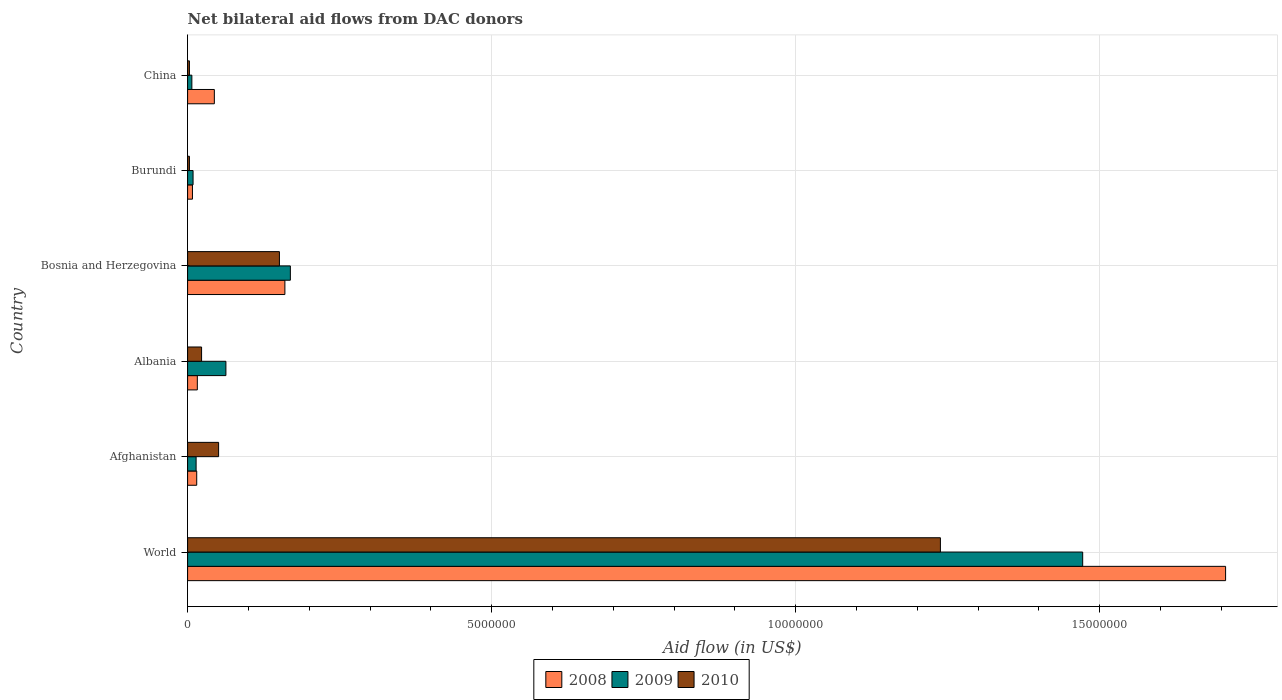How many groups of bars are there?
Ensure brevity in your answer.  6. Are the number of bars on each tick of the Y-axis equal?
Your answer should be compact. Yes. How many bars are there on the 4th tick from the top?
Provide a short and direct response. 3. How many bars are there on the 2nd tick from the bottom?
Provide a short and direct response. 3. What is the label of the 4th group of bars from the top?
Ensure brevity in your answer.  Albania. In how many cases, is the number of bars for a given country not equal to the number of legend labels?
Provide a succinct answer. 0. What is the net bilateral aid flow in 2010 in Albania?
Give a very brief answer. 2.30e+05. Across all countries, what is the maximum net bilateral aid flow in 2010?
Offer a very short reply. 1.24e+07. In which country was the net bilateral aid flow in 2008 minimum?
Provide a succinct answer. Burundi. What is the total net bilateral aid flow in 2010 in the graph?
Your response must be concise. 1.47e+07. What is the difference between the net bilateral aid flow in 2009 in Bosnia and Herzegovina and that in Burundi?
Provide a succinct answer. 1.60e+06. What is the difference between the net bilateral aid flow in 2009 in China and the net bilateral aid flow in 2010 in Afghanistan?
Your answer should be compact. -4.40e+05. What is the average net bilateral aid flow in 2008 per country?
Give a very brief answer. 3.25e+06. What is the difference between the net bilateral aid flow in 2010 and net bilateral aid flow in 2009 in World?
Your answer should be very brief. -2.34e+06. What is the ratio of the net bilateral aid flow in 2010 in Bosnia and Herzegovina to that in Burundi?
Provide a succinct answer. 50.33. Is the net bilateral aid flow in 2008 in Burundi less than that in World?
Make the answer very short. Yes. What is the difference between the highest and the second highest net bilateral aid flow in 2009?
Keep it short and to the point. 1.30e+07. What is the difference between the highest and the lowest net bilateral aid flow in 2009?
Your answer should be very brief. 1.46e+07. What does the 2nd bar from the bottom in Afghanistan represents?
Your answer should be very brief. 2009. Is it the case that in every country, the sum of the net bilateral aid flow in 2009 and net bilateral aid flow in 2008 is greater than the net bilateral aid flow in 2010?
Keep it short and to the point. No. Are all the bars in the graph horizontal?
Provide a succinct answer. Yes. How many countries are there in the graph?
Make the answer very short. 6. Are the values on the major ticks of X-axis written in scientific E-notation?
Keep it short and to the point. No. Does the graph contain grids?
Give a very brief answer. Yes. How many legend labels are there?
Make the answer very short. 3. How are the legend labels stacked?
Your answer should be compact. Horizontal. What is the title of the graph?
Offer a very short reply. Net bilateral aid flows from DAC donors. Does "1962" appear as one of the legend labels in the graph?
Ensure brevity in your answer.  No. What is the label or title of the X-axis?
Provide a short and direct response. Aid flow (in US$). What is the label or title of the Y-axis?
Ensure brevity in your answer.  Country. What is the Aid flow (in US$) of 2008 in World?
Ensure brevity in your answer.  1.71e+07. What is the Aid flow (in US$) in 2009 in World?
Make the answer very short. 1.47e+07. What is the Aid flow (in US$) in 2010 in World?
Your answer should be compact. 1.24e+07. What is the Aid flow (in US$) of 2009 in Afghanistan?
Ensure brevity in your answer.  1.40e+05. What is the Aid flow (in US$) in 2010 in Afghanistan?
Your answer should be very brief. 5.10e+05. What is the Aid flow (in US$) in 2008 in Albania?
Your answer should be compact. 1.60e+05. What is the Aid flow (in US$) in 2009 in Albania?
Give a very brief answer. 6.30e+05. What is the Aid flow (in US$) of 2010 in Albania?
Offer a very short reply. 2.30e+05. What is the Aid flow (in US$) of 2008 in Bosnia and Herzegovina?
Your response must be concise. 1.60e+06. What is the Aid flow (in US$) in 2009 in Bosnia and Herzegovina?
Provide a succinct answer. 1.69e+06. What is the Aid flow (in US$) of 2010 in Bosnia and Herzegovina?
Provide a succinct answer. 1.51e+06. What is the Aid flow (in US$) in 2008 in China?
Keep it short and to the point. 4.40e+05. What is the Aid flow (in US$) of 2009 in China?
Provide a succinct answer. 7.00e+04. What is the Aid flow (in US$) in 2010 in China?
Your response must be concise. 3.00e+04. Across all countries, what is the maximum Aid flow (in US$) of 2008?
Give a very brief answer. 1.71e+07. Across all countries, what is the maximum Aid flow (in US$) of 2009?
Offer a terse response. 1.47e+07. Across all countries, what is the maximum Aid flow (in US$) of 2010?
Your answer should be compact. 1.24e+07. Across all countries, what is the minimum Aid flow (in US$) of 2008?
Ensure brevity in your answer.  8.00e+04. Across all countries, what is the minimum Aid flow (in US$) in 2009?
Ensure brevity in your answer.  7.00e+04. What is the total Aid flow (in US$) in 2008 in the graph?
Ensure brevity in your answer.  1.95e+07. What is the total Aid flow (in US$) of 2009 in the graph?
Offer a very short reply. 1.73e+07. What is the total Aid flow (in US$) in 2010 in the graph?
Offer a terse response. 1.47e+07. What is the difference between the Aid flow (in US$) of 2008 in World and that in Afghanistan?
Provide a succinct answer. 1.69e+07. What is the difference between the Aid flow (in US$) of 2009 in World and that in Afghanistan?
Offer a terse response. 1.46e+07. What is the difference between the Aid flow (in US$) of 2010 in World and that in Afghanistan?
Offer a terse response. 1.19e+07. What is the difference between the Aid flow (in US$) of 2008 in World and that in Albania?
Your answer should be very brief. 1.69e+07. What is the difference between the Aid flow (in US$) in 2009 in World and that in Albania?
Offer a terse response. 1.41e+07. What is the difference between the Aid flow (in US$) of 2010 in World and that in Albania?
Offer a terse response. 1.22e+07. What is the difference between the Aid flow (in US$) in 2008 in World and that in Bosnia and Herzegovina?
Make the answer very short. 1.55e+07. What is the difference between the Aid flow (in US$) of 2009 in World and that in Bosnia and Herzegovina?
Make the answer very short. 1.30e+07. What is the difference between the Aid flow (in US$) in 2010 in World and that in Bosnia and Herzegovina?
Make the answer very short. 1.09e+07. What is the difference between the Aid flow (in US$) of 2008 in World and that in Burundi?
Make the answer very short. 1.70e+07. What is the difference between the Aid flow (in US$) of 2009 in World and that in Burundi?
Keep it short and to the point. 1.46e+07. What is the difference between the Aid flow (in US$) in 2010 in World and that in Burundi?
Provide a succinct answer. 1.24e+07. What is the difference between the Aid flow (in US$) in 2008 in World and that in China?
Give a very brief answer. 1.66e+07. What is the difference between the Aid flow (in US$) of 2009 in World and that in China?
Offer a very short reply. 1.46e+07. What is the difference between the Aid flow (in US$) in 2010 in World and that in China?
Your response must be concise. 1.24e+07. What is the difference between the Aid flow (in US$) of 2008 in Afghanistan and that in Albania?
Offer a very short reply. -10000. What is the difference between the Aid flow (in US$) in 2009 in Afghanistan and that in Albania?
Your response must be concise. -4.90e+05. What is the difference between the Aid flow (in US$) in 2008 in Afghanistan and that in Bosnia and Herzegovina?
Keep it short and to the point. -1.45e+06. What is the difference between the Aid flow (in US$) of 2009 in Afghanistan and that in Bosnia and Herzegovina?
Offer a very short reply. -1.55e+06. What is the difference between the Aid flow (in US$) in 2009 in Afghanistan and that in Burundi?
Your answer should be compact. 5.00e+04. What is the difference between the Aid flow (in US$) in 2010 in Afghanistan and that in China?
Your answer should be compact. 4.80e+05. What is the difference between the Aid flow (in US$) in 2008 in Albania and that in Bosnia and Herzegovina?
Offer a very short reply. -1.44e+06. What is the difference between the Aid flow (in US$) of 2009 in Albania and that in Bosnia and Herzegovina?
Offer a very short reply. -1.06e+06. What is the difference between the Aid flow (in US$) of 2010 in Albania and that in Bosnia and Herzegovina?
Provide a short and direct response. -1.28e+06. What is the difference between the Aid flow (in US$) of 2009 in Albania and that in Burundi?
Offer a very short reply. 5.40e+05. What is the difference between the Aid flow (in US$) of 2008 in Albania and that in China?
Offer a terse response. -2.80e+05. What is the difference between the Aid flow (in US$) of 2009 in Albania and that in China?
Your answer should be compact. 5.60e+05. What is the difference between the Aid flow (in US$) in 2008 in Bosnia and Herzegovina and that in Burundi?
Your answer should be compact. 1.52e+06. What is the difference between the Aid flow (in US$) of 2009 in Bosnia and Herzegovina and that in Burundi?
Ensure brevity in your answer.  1.60e+06. What is the difference between the Aid flow (in US$) in 2010 in Bosnia and Herzegovina and that in Burundi?
Your response must be concise. 1.48e+06. What is the difference between the Aid flow (in US$) of 2008 in Bosnia and Herzegovina and that in China?
Your answer should be very brief. 1.16e+06. What is the difference between the Aid flow (in US$) of 2009 in Bosnia and Herzegovina and that in China?
Make the answer very short. 1.62e+06. What is the difference between the Aid flow (in US$) of 2010 in Bosnia and Herzegovina and that in China?
Your answer should be very brief. 1.48e+06. What is the difference between the Aid flow (in US$) of 2008 in Burundi and that in China?
Your response must be concise. -3.60e+05. What is the difference between the Aid flow (in US$) of 2008 in World and the Aid flow (in US$) of 2009 in Afghanistan?
Offer a very short reply. 1.69e+07. What is the difference between the Aid flow (in US$) of 2008 in World and the Aid flow (in US$) of 2010 in Afghanistan?
Provide a short and direct response. 1.66e+07. What is the difference between the Aid flow (in US$) of 2009 in World and the Aid flow (in US$) of 2010 in Afghanistan?
Offer a very short reply. 1.42e+07. What is the difference between the Aid flow (in US$) of 2008 in World and the Aid flow (in US$) of 2009 in Albania?
Your answer should be compact. 1.64e+07. What is the difference between the Aid flow (in US$) in 2008 in World and the Aid flow (in US$) in 2010 in Albania?
Provide a short and direct response. 1.68e+07. What is the difference between the Aid flow (in US$) of 2009 in World and the Aid flow (in US$) of 2010 in Albania?
Your response must be concise. 1.45e+07. What is the difference between the Aid flow (in US$) in 2008 in World and the Aid flow (in US$) in 2009 in Bosnia and Herzegovina?
Your answer should be compact. 1.54e+07. What is the difference between the Aid flow (in US$) in 2008 in World and the Aid flow (in US$) in 2010 in Bosnia and Herzegovina?
Your answer should be very brief. 1.56e+07. What is the difference between the Aid flow (in US$) of 2009 in World and the Aid flow (in US$) of 2010 in Bosnia and Herzegovina?
Ensure brevity in your answer.  1.32e+07. What is the difference between the Aid flow (in US$) in 2008 in World and the Aid flow (in US$) in 2009 in Burundi?
Your answer should be very brief. 1.70e+07. What is the difference between the Aid flow (in US$) in 2008 in World and the Aid flow (in US$) in 2010 in Burundi?
Your answer should be compact. 1.70e+07. What is the difference between the Aid flow (in US$) in 2009 in World and the Aid flow (in US$) in 2010 in Burundi?
Make the answer very short. 1.47e+07. What is the difference between the Aid flow (in US$) of 2008 in World and the Aid flow (in US$) of 2009 in China?
Make the answer very short. 1.70e+07. What is the difference between the Aid flow (in US$) of 2008 in World and the Aid flow (in US$) of 2010 in China?
Your answer should be compact. 1.70e+07. What is the difference between the Aid flow (in US$) in 2009 in World and the Aid flow (in US$) in 2010 in China?
Offer a very short reply. 1.47e+07. What is the difference between the Aid flow (in US$) of 2008 in Afghanistan and the Aid flow (in US$) of 2009 in Albania?
Provide a succinct answer. -4.80e+05. What is the difference between the Aid flow (in US$) of 2009 in Afghanistan and the Aid flow (in US$) of 2010 in Albania?
Offer a very short reply. -9.00e+04. What is the difference between the Aid flow (in US$) in 2008 in Afghanistan and the Aid flow (in US$) in 2009 in Bosnia and Herzegovina?
Make the answer very short. -1.54e+06. What is the difference between the Aid flow (in US$) of 2008 in Afghanistan and the Aid flow (in US$) of 2010 in Bosnia and Herzegovina?
Ensure brevity in your answer.  -1.36e+06. What is the difference between the Aid flow (in US$) of 2009 in Afghanistan and the Aid flow (in US$) of 2010 in Bosnia and Herzegovina?
Your response must be concise. -1.37e+06. What is the difference between the Aid flow (in US$) in 2008 in Afghanistan and the Aid flow (in US$) in 2010 in Burundi?
Provide a succinct answer. 1.20e+05. What is the difference between the Aid flow (in US$) in 2009 in Afghanistan and the Aid flow (in US$) in 2010 in Burundi?
Ensure brevity in your answer.  1.10e+05. What is the difference between the Aid flow (in US$) in 2008 in Albania and the Aid flow (in US$) in 2009 in Bosnia and Herzegovina?
Make the answer very short. -1.53e+06. What is the difference between the Aid flow (in US$) of 2008 in Albania and the Aid flow (in US$) of 2010 in Bosnia and Herzegovina?
Your answer should be compact. -1.35e+06. What is the difference between the Aid flow (in US$) of 2009 in Albania and the Aid flow (in US$) of 2010 in Bosnia and Herzegovina?
Ensure brevity in your answer.  -8.80e+05. What is the difference between the Aid flow (in US$) of 2008 in Albania and the Aid flow (in US$) of 2010 in Burundi?
Provide a succinct answer. 1.30e+05. What is the difference between the Aid flow (in US$) of 2008 in Albania and the Aid flow (in US$) of 2009 in China?
Ensure brevity in your answer.  9.00e+04. What is the difference between the Aid flow (in US$) in 2008 in Albania and the Aid flow (in US$) in 2010 in China?
Ensure brevity in your answer.  1.30e+05. What is the difference between the Aid flow (in US$) in 2009 in Albania and the Aid flow (in US$) in 2010 in China?
Give a very brief answer. 6.00e+05. What is the difference between the Aid flow (in US$) of 2008 in Bosnia and Herzegovina and the Aid flow (in US$) of 2009 in Burundi?
Provide a succinct answer. 1.51e+06. What is the difference between the Aid flow (in US$) in 2008 in Bosnia and Herzegovina and the Aid flow (in US$) in 2010 in Burundi?
Provide a short and direct response. 1.57e+06. What is the difference between the Aid flow (in US$) in 2009 in Bosnia and Herzegovina and the Aid flow (in US$) in 2010 in Burundi?
Provide a succinct answer. 1.66e+06. What is the difference between the Aid flow (in US$) of 2008 in Bosnia and Herzegovina and the Aid flow (in US$) of 2009 in China?
Keep it short and to the point. 1.53e+06. What is the difference between the Aid flow (in US$) in 2008 in Bosnia and Herzegovina and the Aid flow (in US$) in 2010 in China?
Give a very brief answer. 1.57e+06. What is the difference between the Aid flow (in US$) in 2009 in Bosnia and Herzegovina and the Aid flow (in US$) in 2010 in China?
Your response must be concise. 1.66e+06. What is the difference between the Aid flow (in US$) of 2008 in Burundi and the Aid flow (in US$) of 2010 in China?
Keep it short and to the point. 5.00e+04. What is the difference between the Aid flow (in US$) in 2009 in Burundi and the Aid flow (in US$) in 2010 in China?
Make the answer very short. 6.00e+04. What is the average Aid flow (in US$) of 2008 per country?
Give a very brief answer. 3.25e+06. What is the average Aid flow (in US$) of 2009 per country?
Ensure brevity in your answer.  2.89e+06. What is the average Aid flow (in US$) in 2010 per country?
Your answer should be very brief. 2.45e+06. What is the difference between the Aid flow (in US$) in 2008 and Aid flow (in US$) in 2009 in World?
Provide a succinct answer. 2.35e+06. What is the difference between the Aid flow (in US$) of 2008 and Aid flow (in US$) of 2010 in World?
Give a very brief answer. 4.69e+06. What is the difference between the Aid flow (in US$) in 2009 and Aid flow (in US$) in 2010 in World?
Give a very brief answer. 2.34e+06. What is the difference between the Aid flow (in US$) in 2008 and Aid flow (in US$) in 2009 in Afghanistan?
Provide a short and direct response. 10000. What is the difference between the Aid flow (in US$) in 2008 and Aid flow (in US$) in 2010 in Afghanistan?
Offer a very short reply. -3.60e+05. What is the difference between the Aid flow (in US$) in 2009 and Aid flow (in US$) in 2010 in Afghanistan?
Provide a succinct answer. -3.70e+05. What is the difference between the Aid flow (in US$) of 2008 and Aid flow (in US$) of 2009 in Albania?
Make the answer very short. -4.70e+05. What is the difference between the Aid flow (in US$) in 2009 and Aid flow (in US$) in 2010 in Albania?
Make the answer very short. 4.00e+05. What is the difference between the Aid flow (in US$) of 2008 and Aid flow (in US$) of 2009 in Burundi?
Give a very brief answer. -10000. What is the difference between the Aid flow (in US$) of 2008 and Aid flow (in US$) of 2009 in China?
Make the answer very short. 3.70e+05. What is the difference between the Aid flow (in US$) of 2008 and Aid flow (in US$) of 2010 in China?
Your answer should be compact. 4.10e+05. What is the difference between the Aid flow (in US$) of 2009 and Aid flow (in US$) of 2010 in China?
Give a very brief answer. 4.00e+04. What is the ratio of the Aid flow (in US$) in 2008 in World to that in Afghanistan?
Keep it short and to the point. 113.8. What is the ratio of the Aid flow (in US$) of 2009 in World to that in Afghanistan?
Your answer should be compact. 105.14. What is the ratio of the Aid flow (in US$) in 2010 in World to that in Afghanistan?
Offer a very short reply. 24.27. What is the ratio of the Aid flow (in US$) in 2008 in World to that in Albania?
Give a very brief answer. 106.69. What is the ratio of the Aid flow (in US$) in 2009 in World to that in Albania?
Offer a terse response. 23.37. What is the ratio of the Aid flow (in US$) of 2010 in World to that in Albania?
Give a very brief answer. 53.83. What is the ratio of the Aid flow (in US$) in 2008 in World to that in Bosnia and Herzegovina?
Provide a short and direct response. 10.67. What is the ratio of the Aid flow (in US$) in 2009 in World to that in Bosnia and Herzegovina?
Provide a succinct answer. 8.71. What is the ratio of the Aid flow (in US$) of 2010 in World to that in Bosnia and Herzegovina?
Provide a short and direct response. 8.2. What is the ratio of the Aid flow (in US$) in 2008 in World to that in Burundi?
Provide a short and direct response. 213.38. What is the ratio of the Aid flow (in US$) in 2009 in World to that in Burundi?
Your response must be concise. 163.56. What is the ratio of the Aid flow (in US$) of 2010 in World to that in Burundi?
Make the answer very short. 412.67. What is the ratio of the Aid flow (in US$) of 2008 in World to that in China?
Keep it short and to the point. 38.8. What is the ratio of the Aid flow (in US$) in 2009 in World to that in China?
Your answer should be compact. 210.29. What is the ratio of the Aid flow (in US$) in 2010 in World to that in China?
Your answer should be very brief. 412.67. What is the ratio of the Aid flow (in US$) in 2008 in Afghanistan to that in Albania?
Make the answer very short. 0.94. What is the ratio of the Aid flow (in US$) of 2009 in Afghanistan to that in Albania?
Give a very brief answer. 0.22. What is the ratio of the Aid flow (in US$) in 2010 in Afghanistan to that in Albania?
Provide a short and direct response. 2.22. What is the ratio of the Aid flow (in US$) in 2008 in Afghanistan to that in Bosnia and Herzegovina?
Offer a very short reply. 0.09. What is the ratio of the Aid flow (in US$) of 2009 in Afghanistan to that in Bosnia and Herzegovina?
Make the answer very short. 0.08. What is the ratio of the Aid flow (in US$) of 2010 in Afghanistan to that in Bosnia and Herzegovina?
Offer a terse response. 0.34. What is the ratio of the Aid flow (in US$) of 2008 in Afghanistan to that in Burundi?
Keep it short and to the point. 1.88. What is the ratio of the Aid flow (in US$) of 2009 in Afghanistan to that in Burundi?
Your response must be concise. 1.56. What is the ratio of the Aid flow (in US$) in 2008 in Afghanistan to that in China?
Make the answer very short. 0.34. What is the ratio of the Aid flow (in US$) of 2010 in Afghanistan to that in China?
Ensure brevity in your answer.  17. What is the ratio of the Aid flow (in US$) of 2009 in Albania to that in Bosnia and Herzegovina?
Offer a very short reply. 0.37. What is the ratio of the Aid flow (in US$) of 2010 in Albania to that in Bosnia and Herzegovina?
Your answer should be very brief. 0.15. What is the ratio of the Aid flow (in US$) of 2008 in Albania to that in Burundi?
Give a very brief answer. 2. What is the ratio of the Aid flow (in US$) of 2009 in Albania to that in Burundi?
Provide a short and direct response. 7. What is the ratio of the Aid flow (in US$) of 2010 in Albania to that in Burundi?
Provide a succinct answer. 7.67. What is the ratio of the Aid flow (in US$) of 2008 in Albania to that in China?
Provide a succinct answer. 0.36. What is the ratio of the Aid flow (in US$) of 2009 in Albania to that in China?
Ensure brevity in your answer.  9. What is the ratio of the Aid flow (in US$) in 2010 in Albania to that in China?
Give a very brief answer. 7.67. What is the ratio of the Aid flow (in US$) of 2008 in Bosnia and Herzegovina to that in Burundi?
Offer a terse response. 20. What is the ratio of the Aid flow (in US$) of 2009 in Bosnia and Herzegovina to that in Burundi?
Offer a terse response. 18.78. What is the ratio of the Aid flow (in US$) in 2010 in Bosnia and Herzegovina to that in Burundi?
Make the answer very short. 50.33. What is the ratio of the Aid flow (in US$) in 2008 in Bosnia and Herzegovina to that in China?
Make the answer very short. 3.64. What is the ratio of the Aid flow (in US$) of 2009 in Bosnia and Herzegovina to that in China?
Your answer should be compact. 24.14. What is the ratio of the Aid flow (in US$) in 2010 in Bosnia and Herzegovina to that in China?
Offer a very short reply. 50.33. What is the ratio of the Aid flow (in US$) in 2008 in Burundi to that in China?
Offer a very short reply. 0.18. What is the difference between the highest and the second highest Aid flow (in US$) in 2008?
Provide a short and direct response. 1.55e+07. What is the difference between the highest and the second highest Aid flow (in US$) in 2009?
Keep it short and to the point. 1.30e+07. What is the difference between the highest and the second highest Aid flow (in US$) of 2010?
Provide a succinct answer. 1.09e+07. What is the difference between the highest and the lowest Aid flow (in US$) in 2008?
Keep it short and to the point. 1.70e+07. What is the difference between the highest and the lowest Aid flow (in US$) of 2009?
Keep it short and to the point. 1.46e+07. What is the difference between the highest and the lowest Aid flow (in US$) of 2010?
Provide a short and direct response. 1.24e+07. 